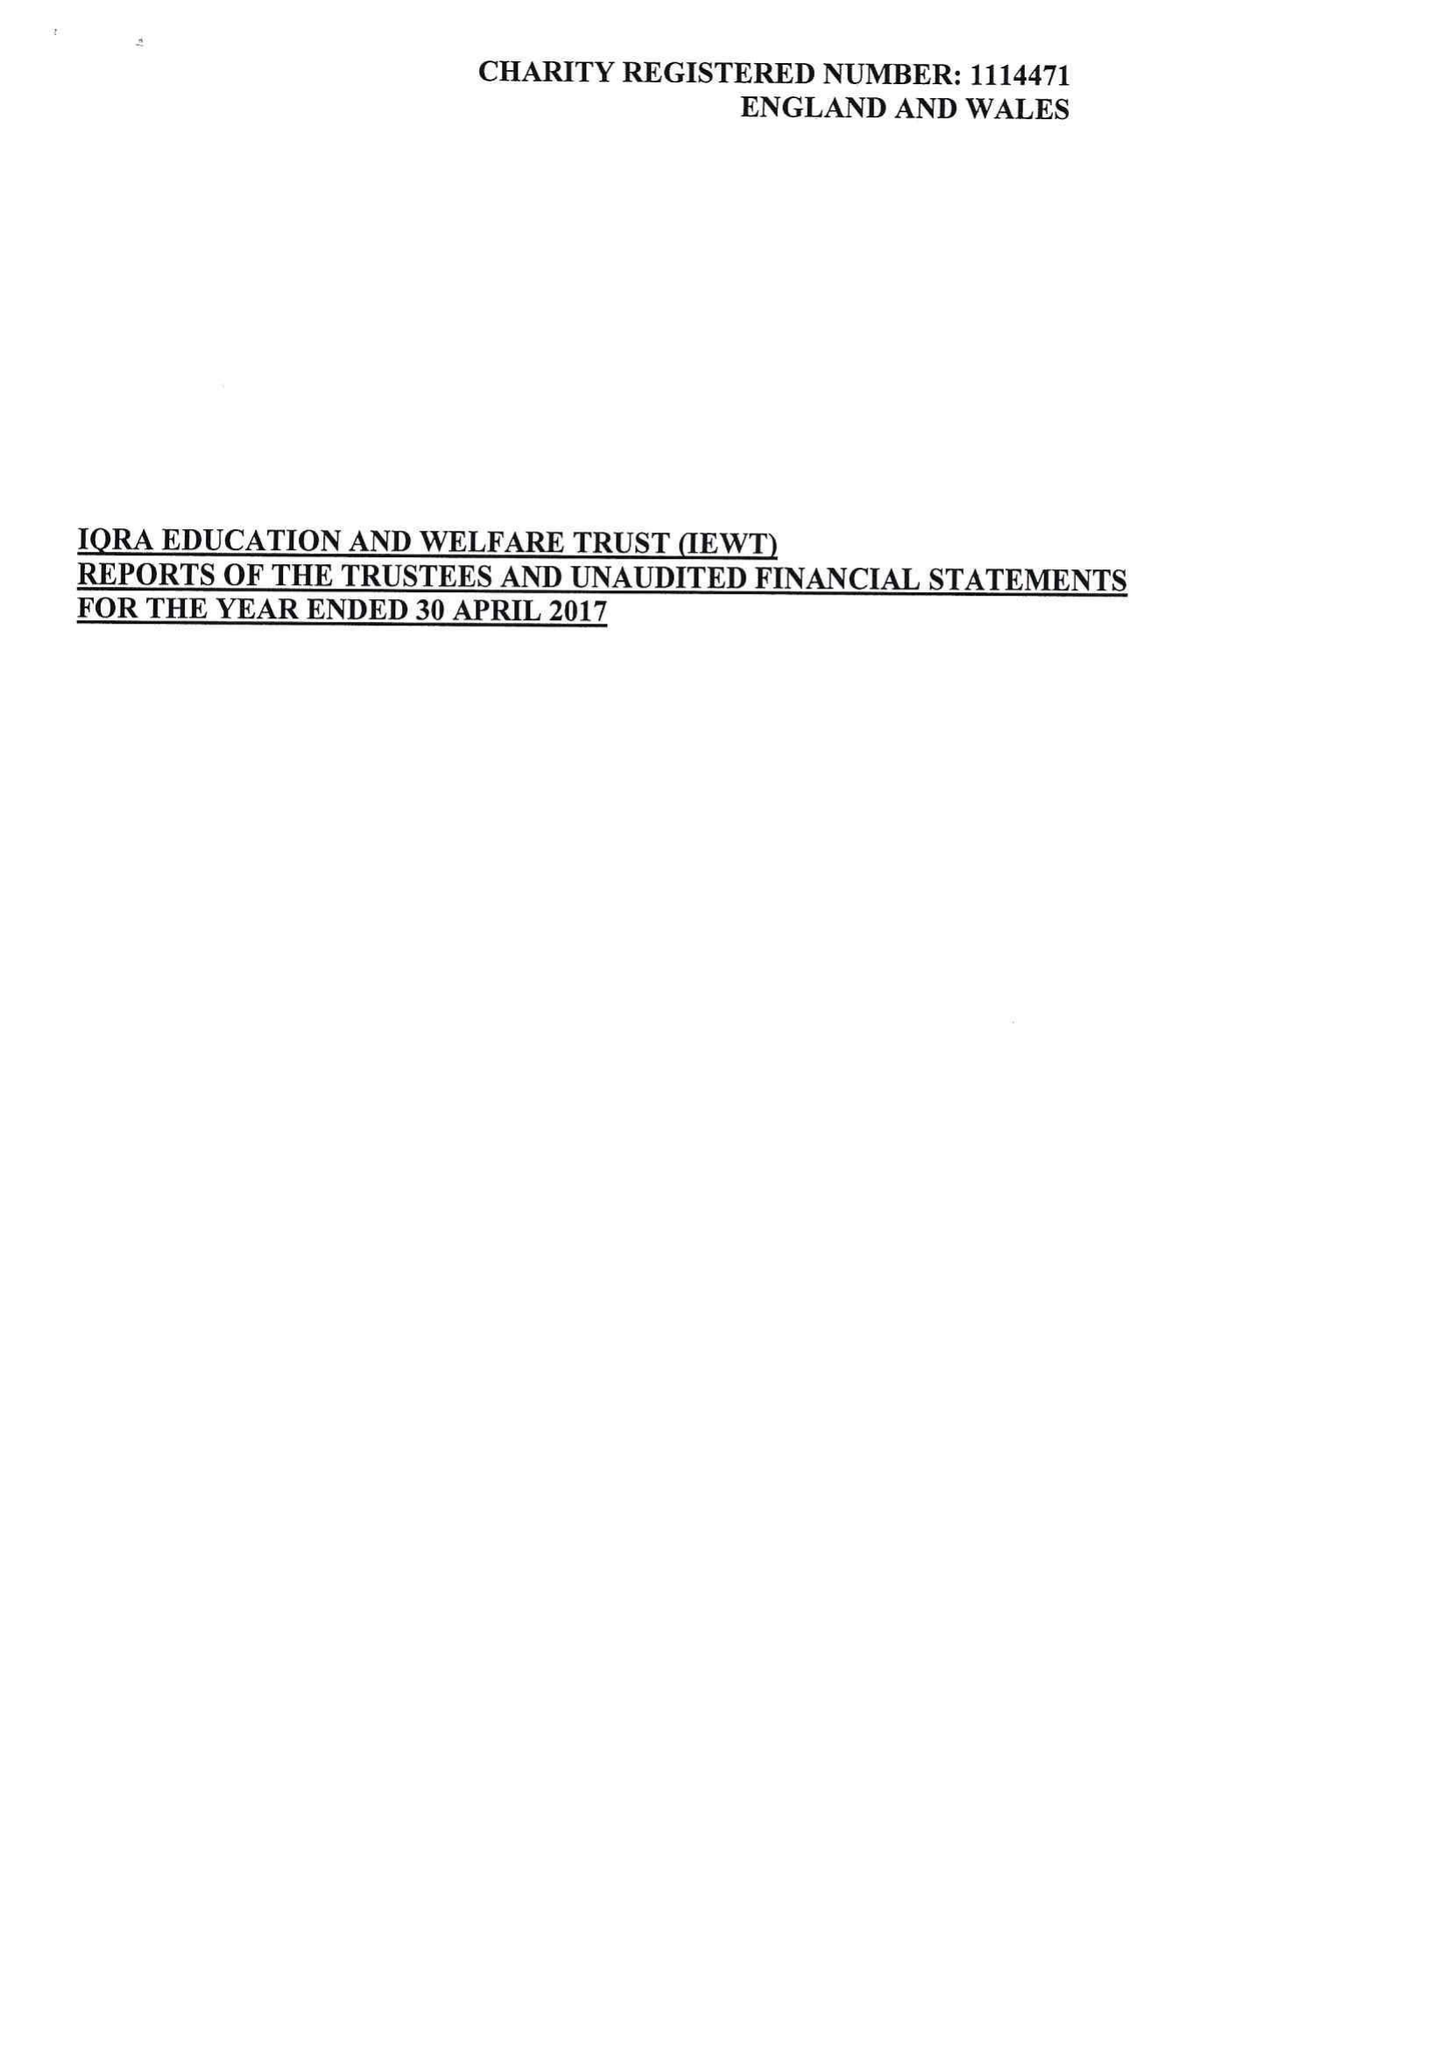What is the value for the spending_annually_in_british_pounds?
Answer the question using a single word or phrase. 96571.00 